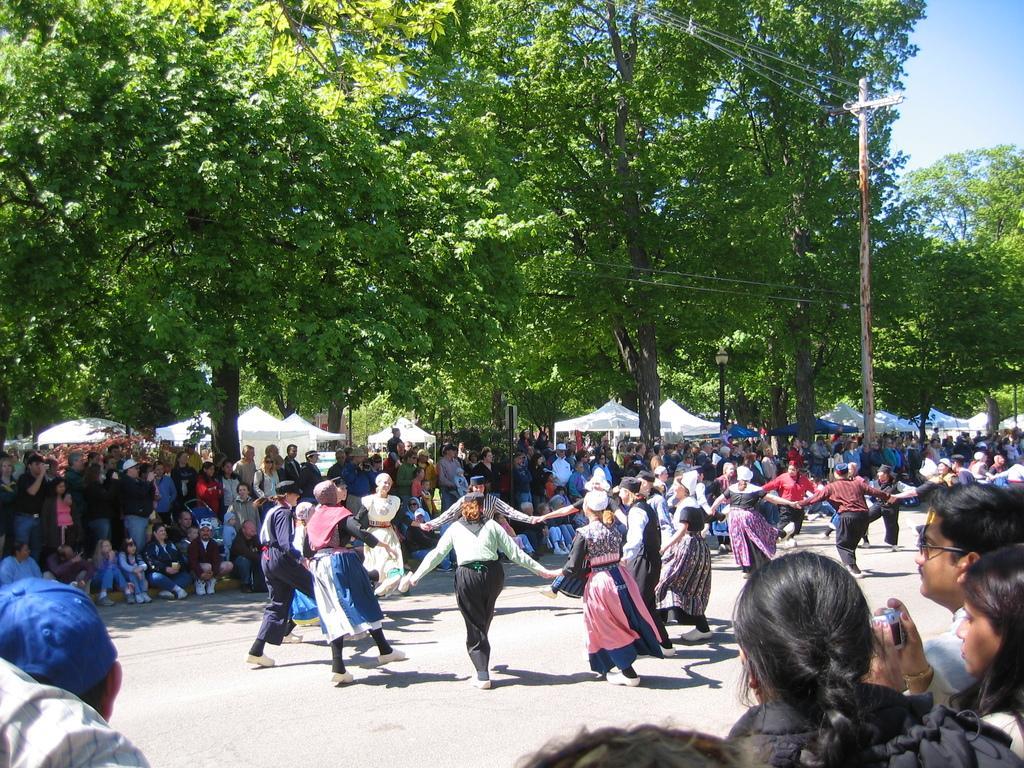Describe this image in one or two sentences. In the picture I can see a group of people. I can see a few of them dancing on the road and a few of them are standing on the side of the road. There is a woman on the bottom right side and she is holding the camera in her hands. I can see an electric pole on the right side of the picture. In the background, I can see the tents and trees. 